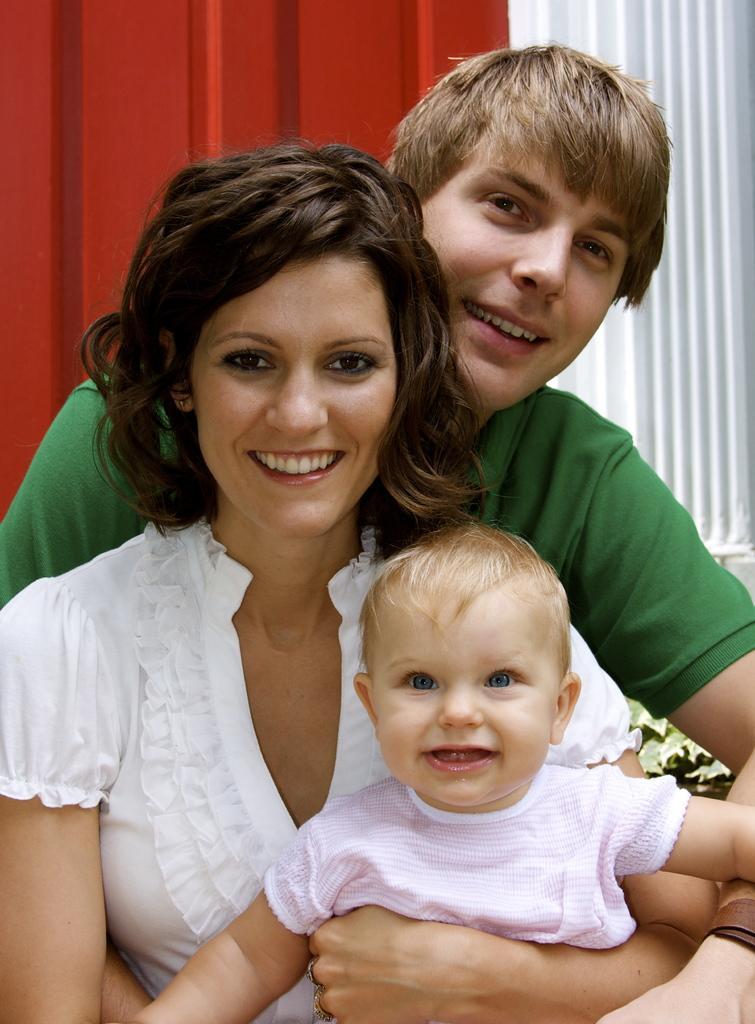Can you describe this image briefly? Here we can see a woman and a man are holding a kid in their hands and in the background there is a metal sheet and a plant. 